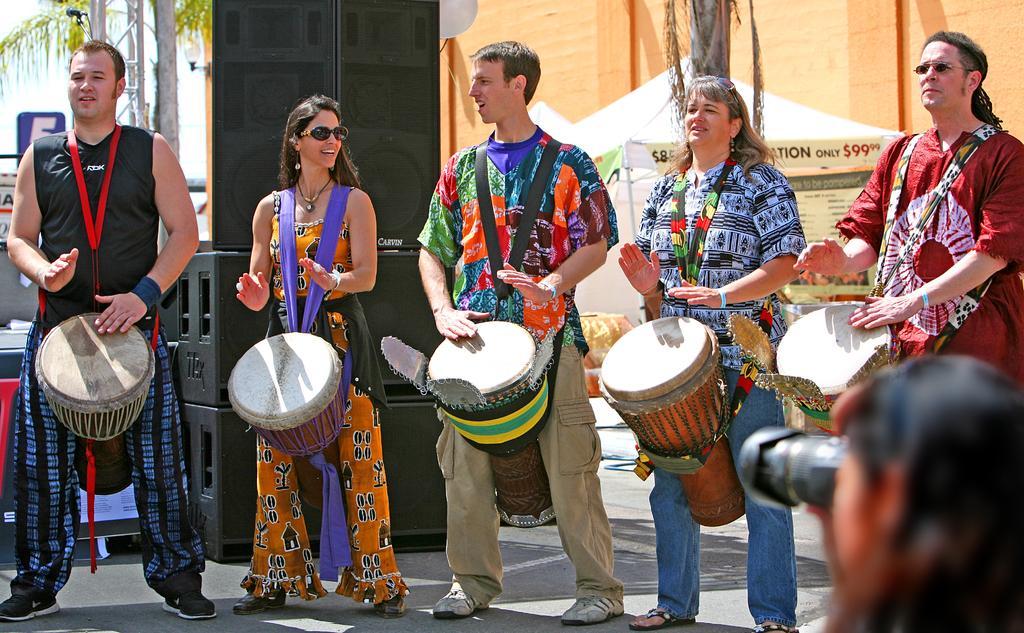Can you describe this image briefly? It is a an event there are group of people playing the drums there are three men and two women among them,in the background there are big speakers there is also a tent that are live counters and also some trees and sky. 